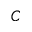<formula> <loc_0><loc_0><loc_500><loc_500>C</formula> 